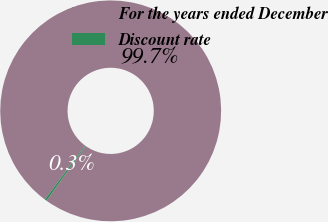Convert chart. <chart><loc_0><loc_0><loc_500><loc_500><pie_chart><fcel>For the years ended December<fcel>Discount rate<nl><fcel>99.71%<fcel>0.29%<nl></chart> 